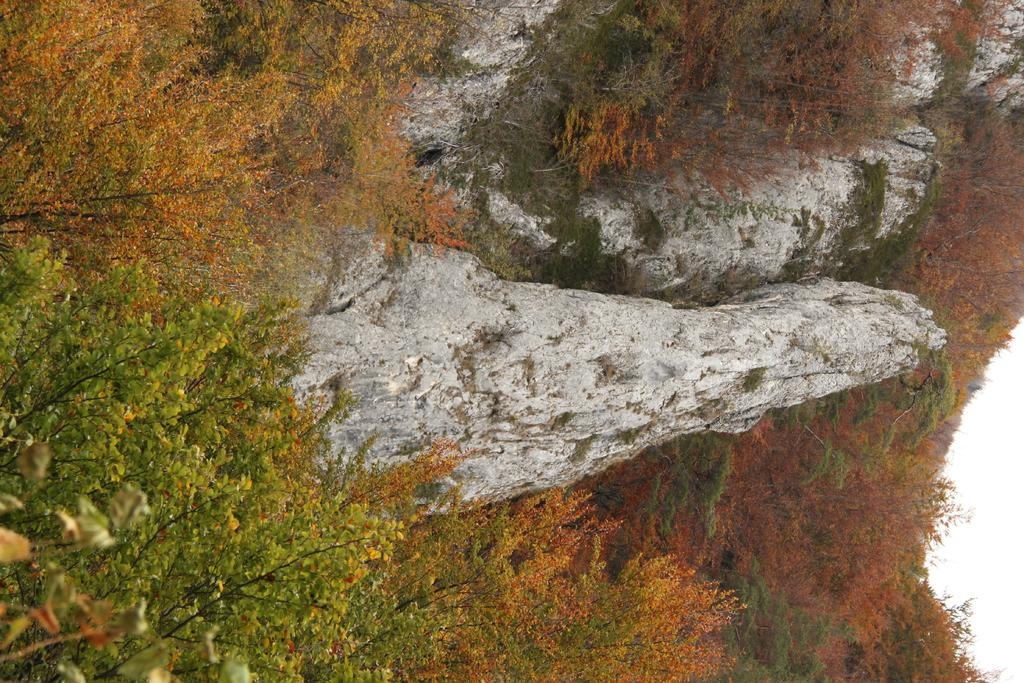What type of vegetation can be seen in the image? There are plants and trees in the image. What type of natural feature is visible in the background of the image? There are mountains in the image. What color is the brick used to build the fence in the image? There is no fence or brick present in the image. What type of experience can be gained from the image? The image is a static representation and does not offer any experience. 